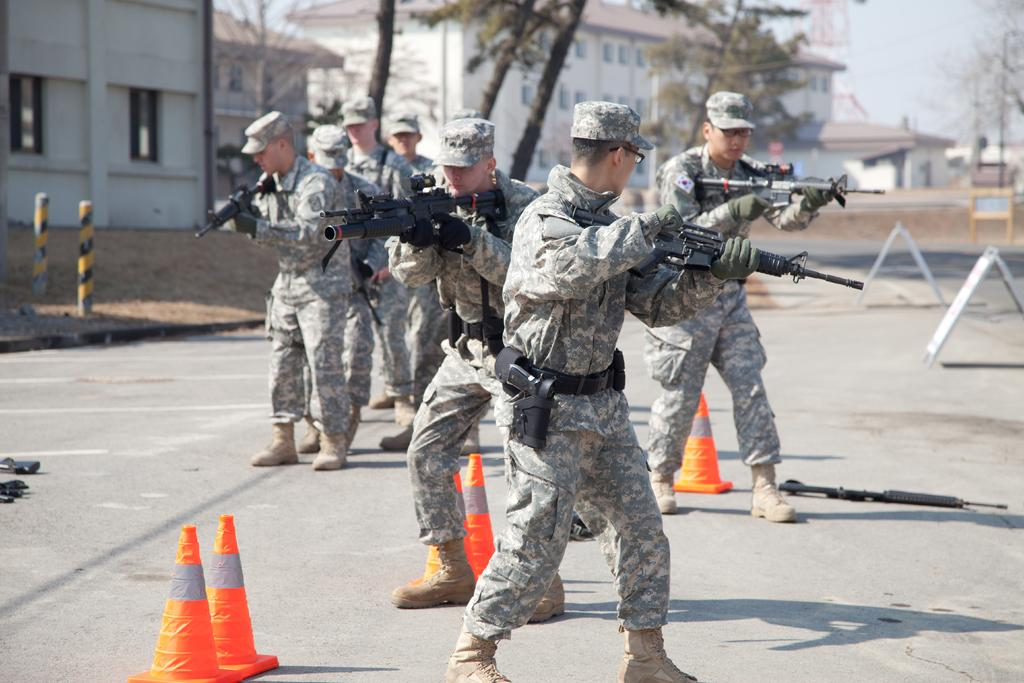What type of people can be seen in the image? There are army people in the image. Where are the army people located in the image? The army people are standing on the road. What are the army people holding in the image? The army people are holding guns. What type of clothing are the army people wearing in the image? The army people are wearing uniforms and caps. What can be seen in the background of the image? There are buildings, trees, and the sky visible in the background of the image. What type of powder is being used by the army people in the image? There is no powder visible or mentioned in the image; the army people are holding guns and wearing uniforms. What religion are the army people practicing in the image? There is no indication of religion in the image; the focus is on the army people and their actions. 